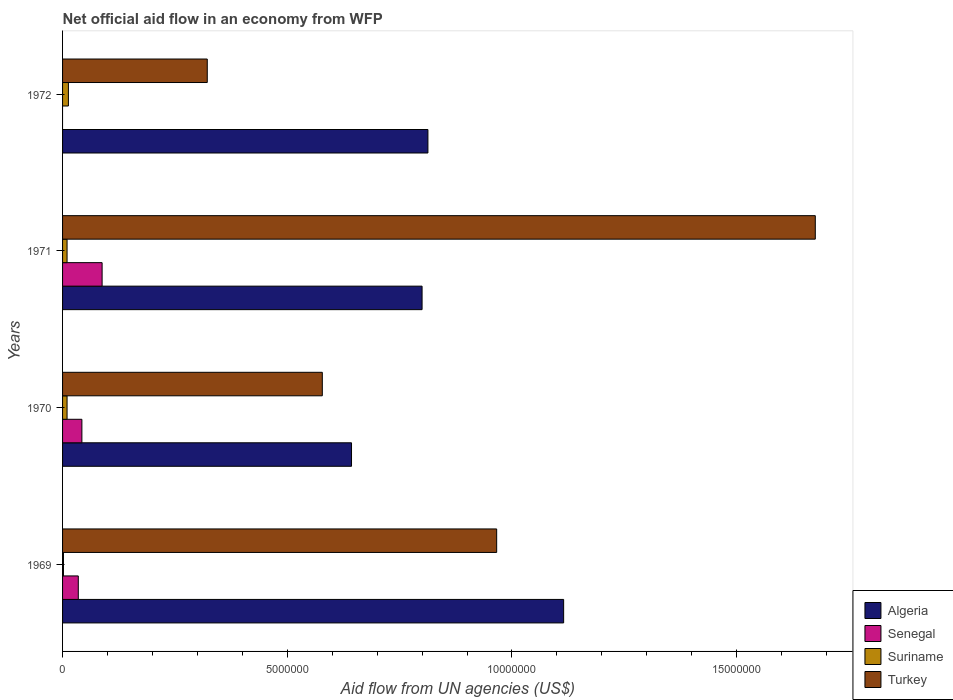How many different coloured bars are there?
Make the answer very short. 4. How many groups of bars are there?
Your response must be concise. 4. How many bars are there on the 3rd tick from the top?
Your answer should be compact. 4. How many bars are there on the 4th tick from the bottom?
Provide a succinct answer. 3. What is the label of the 2nd group of bars from the top?
Provide a short and direct response. 1971. In how many cases, is the number of bars for a given year not equal to the number of legend labels?
Provide a short and direct response. 1. What is the net official aid flow in Turkey in 1970?
Your answer should be very brief. 5.78e+06. Across all years, what is the maximum net official aid flow in Algeria?
Provide a short and direct response. 1.12e+07. Across all years, what is the minimum net official aid flow in Algeria?
Your answer should be very brief. 6.43e+06. What is the total net official aid flow in Senegal in the graph?
Your answer should be very brief. 1.66e+06. What is the difference between the net official aid flow in Algeria in 1970 and that in 1971?
Provide a succinct answer. -1.57e+06. What is the difference between the net official aid flow in Algeria in 1970 and the net official aid flow in Suriname in 1969?
Your answer should be compact. 6.41e+06. What is the average net official aid flow in Senegal per year?
Your answer should be very brief. 4.15e+05. In the year 1969, what is the difference between the net official aid flow in Senegal and net official aid flow in Turkey?
Your answer should be compact. -9.31e+06. In how many years, is the net official aid flow in Suriname greater than 4000000 US$?
Ensure brevity in your answer.  0. What is the ratio of the net official aid flow in Algeria in 1970 to that in 1971?
Offer a very short reply. 0.8. What is the difference between the highest and the second highest net official aid flow in Algeria?
Make the answer very short. 3.02e+06. In how many years, is the net official aid flow in Senegal greater than the average net official aid flow in Senegal taken over all years?
Ensure brevity in your answer.  2. Is it the case that in every year, the sum of the net official aid flow in Algeria and net official aid flow in Senegal is greater than the sum of net official aid flow in Turkey and net official aid flow in Suriname?
Make the answer very short. No. How many bars are there?
Offer a very short reply. 15. What is the difference between two consecutive major ticks on the X-axis?
Keep it short and to the point. 5.00e+06. Are the values on the major ticks of X-axis written in scientific E-notation?
Give a very brief answer. No. Does the graph contain any zero values?
Provide a short and direct response. Yes. Does the graph contain grids?
Make the answer very short. No. How are the legend labels stacked?
Provide a succinct answer. Vertical. What is the title of the graph?
Offer a very short reply. Net official aid flow in an economy from WFP. What is the label or title of the X-axis?
Keep it short and to the point. Aid flow from UN agencies (US$). What is the label or title of the Y-axis?
Your answer should be compact. Years. What is the Aid flow from UN agencies (US$) in Algeria in 1969?
Your response must be concise. 1.12e+07. What is the Aid flow from UN agencies (US$) in Senegal in 1969?
Keep it short and to the point. 3.50e+05. What is the Aid flow from UN agencies (US$) in Turkey in 1969?
Offer a terse response. 9.66e+06. What is the Aid flow from UN agencies (US$) of Algeria in 1970?
Your response must be concise. 6.43e+06. What is the Aid flow from UN agencies (US$) of Senegal in 1970?
Your answer should be very brief. 4.30e+05. What is the Aid flow from UN agencies (US$) in Turkey in 1970?
Ensure brevity in your answer.  5.78e+06. What is the Aid flow from UN agencies (US$) in Senegal in 1971?
Ensure brevity in your answer.  8.80e+05. What is the Aid flow from UN agencies (US$) of Suriname in 1971?
Your answer should be compact. 1.00e+05. What is the Aid flow from UN agencies (US$) of Turkey in 1971?
Provide a succinct answer. 1.68e+07. What is the Aid flow from UN agencies (US$) of Algeria in 1972?
Offer a very short reply. 8.13e+06. What is the Aid flow from UN agencies (US$) in Senegal in 1972?
Give a very brief answer. 0. What is the Aid flow from UN agencies (US$) in Turkey in 1972?
Provide a succinct answer. 3.22e+06. Across all years, what is the maximum Aid flow from UN agencies (US$) of Algeria?
Your response must be concise. 1.12e+07. Across all years, what is the maximum Aid flow from UN agencies (US$) in Senegal?
Your response must be concise. 8.80e+05. Across all years, what is the maximum Aid flow from UN agencies (US$) of Turkey?
Offer a terse response. 1.68e+07. Across all years, what is the minimum Aid flow from UN agencies (US$) in Algeria?
Provide a succinct answer. 6.43e+06. Across all years, what is the minimum Aid flow from UN agencies (US$) of Suriname?
Ensure brevity in your answer.  2.00e+04. Across all years, what is the minimum Aid flow from UN agencies (US$) of Turkey?
Offer a terse response. 3.22e+06. What is the total Aid flow from UN agencies (US$) in Algeria in the graph?
Your answer should be very brief. 3.37e+07. What is the total Aid flow from UN agencies (US$) in Senegal in the graph?
Provide a short and direct response. 1.66e+06. What is the total Aid flow from UN agencies (US$) in Suriname in the graph?
Ensure brevity in your answer.  3.50e+05. What is the total Aid flow from UN agencies (US$) in Turkey in the graph?
Offer a very short reply. 3.54e+07. What is the difference between the Aid flow from UN agencies (US$) in Algeria in 1969 and that in 1970?
Offer a terse response. 4.72e+06. What is the difference between the Aid flow from UN agencies (US$) of Turkey in 1969 and that in 1970?
Offer a terse response. 3.88e+06. What is the difference between the Aid flow from UN agencies (US$) of Algeria in 1969 and that in 1971?
Provide a short and direct response. 3.15e+06. What is the difference between the Aid flow from UN agencies (US$) in Senegal in 1969 and that in 1971?
Provide a short and direct response. -5.30e+05. What is the difference between the Aid flow from UN agencies (US$) of Turkey in 1969 and that in 1971?
Your answer should be compact. -7.09e+06. What is the difference between the Aid flow from UN agencies (US$) in Algeria in 1969 and that in 1972?
Your response must be concise. 3.02e+06. What is the difference between the Aid flow from UN agencies (US$) in Suriname in 1969 and that in 1972?
Keep it short and to the point. -1.10e+05. What is the difference between the Aid flow from UN agencies (US$) of Turkey in 1969 and that in 1972?
Provide a short and direct response. 6.44e+06. What is the difference between the Aid flow from UN agencies (US$) in Algeria in 1970 and that in 1971?
Your response must be concise. -1.57e+06. What is the difference between the Aid flow from UN agencies (US$) of Senegal in 1970 and that in 1971?
Make the answer very short. -4.50e+05. What is the difference between the Aid flow from UN agencies (US$) in Suriname in 1970 and that in 1971?
Give a very brief answer. 0. What is the difference between the Aid flow from UN agencies (US$) in Turkey in 1970 and that in 1971?
Provide a short and direct response. -1.10e+07. What is the difference between the Aid flow from UN agencies (US$) of Algeria in 1970 and that in 1972?
Provide a succinct answer. -1.70e+06. What is the difference between the Aid flow from UN agencies (US$) in Turkey in 1970 and that in 1972?
Your answer should be very brief. 2.56e+06. What is the difference between the Aid flow from UN agencies (US$) of Algeria in 1971 and that in 1972?
Offer a terse response. -1.30e+05. What is the difference between the Aid flow from UN agencies (US$) of Turkey in 1971 and that in 1972?
Offer a very short reply. 1.35e+07. What is the difference between the Aid flow from UN agencies (US$) of Algeria in 1969 and the Aid flow from UN agencies (US$) of Senegal in 1970?
Ensure brevity in your answer.  1.07e+07. What is the difference between the Aid flow from UN agencies (US$) in Algeria in 1969 and the Aid flow from UN agencies (US$) in Suriname in 1970?
Offer a terse response. 1.10e+07. What is the difference between the Aid flow from UN agencies (US$) in Algeria in 1969 and the Aid flow from UN agencies (US$) in Turkey in 1970?
Provide a succinct answer. 5.37e+06. What is the difference between the Aid flow from UN agencies (US$) of Senegal in 1969 and the Aid flow from UN agencies (US$) of Suriname in 1970?
Your answer should be very brief. 2.50e+05. What is the difference between the Aid flow from UN agencies (US$) of Senegal in 1969 and the Aid flow from UN agencies (US$) of Turkey in 1970?
Offer a terse response. -5.43e+06. What is the difference between the Aid flow from UN agencies (US$) of Suriname in 1969 and the Aid flow from UN agencies (US$) of Turkey in 1970?
Ensure brevity in your answer.  -5.76e+06. What is the difference between the Aid flow from UN agencies (US$) of Algeria in 1969 and the Aid flow from UN agencies (US$) of Senegal in 1971?
Offer a very short reply. 1.03e+07. What is the difference between the Aid flow from UN agencies (US$) in Algeria in 1969 and the Aid flow from UN agencies (US$) in Suriname in 1971?
Provide a short and direct response. 1.10e+07. What is the difference between the Aid flow from UN agencies (US$) of Algeria in 1969 and the Aid flow from UN agencies (US$) of Turkey in 1971?
Offer a very short reply. -5.60e+06. What is the difference between the Aid flow from UN agencies (US$) of Senegal in 1969 and the Aid flow from UN agencies (US$) of Turkey in 1971?
Keep it short and to the point. -1.64e+07. What is the difference between the Aid flow from UN agencies (US$) in Suriname in 1969 and the Aid flow from UN agencies (US$) in Turkey in 1971?
Offer a terse response. -1.67e+07. What is the difference between the Aid flow from UN agencies (US$) in Algeria in 1969 and the Aid flow from UN agencies (US$) in Suriname in 1972?
Provide a short and direct response. 1.10e+07. What is the difference between the Aid flow from UN agencies (US$) in Algeria in 1969 and the Aid flow from UN agencies (US$) in Turkey in 1972?
Your answer should be very brief. 7.93e+06. What is the difference between the Aid flow from UN agencies (US$) in Senegal in 1969 and the Aid flow from UN agencies (US$) in Suriname in 1972?
Keep it short and to the point. 2.20e+05. What is the difference between the Aid flow from UN agencies (US$) in Senegal in 1969 and the Aid flow from UN agencies (US$) in Turkey in 1972?
Your answer should be compact. -2.87e+06. What is the difference between the Aid flow from UN agencies (US$) of Suriname in 1969 and the Aid flow from UN agencies (US$) of Turkey in 1972?
Offer a very short reply. -3.20e+06. What is the difference between the Aid flow from UN agencies (US$) in Algeria in 1970 and the Aid flow from UN agencies (US$) in Senegal in 1971?
Your response must be concise. 5.55e+06. What is the difference between the Aid flow from UN agencies (US$) of Algeria in 1970 and the Aid flow from UN agencies (US$) of Suriname in 1971?
Your answer should be compact. 6.33e+06. What is the difference between the Aid flow from UN agencies (US$) in Algeria in 1970 and the Aid flow from UN agencies (US$) in Turkey in 1971?
Make the answer very short. -1.03e+07. What is the difference between the Aid flow from UN agencies (US$) in Senegal in 1970 and the Aid flow from UN agencies (US$) in Turkey in 1971?
Provide a succinct answer. -1.63e+07. What is the difference between the Aid flow from UN agencies (US$) of Suriname in 1970 and the Aid flow from UN agencies (US$) of Turkey in 1971?
Your answer should be very brief. -1.66e+07. What is the difference between the Aid flow from UN agencies (US$) in Algeria in 1970 and the Aid flow from UN agencies (US$) in Suriname in 1972?
Make the answer very short. 6.30e+06. What is the difference between the Aid flow from UN agencies (US$) in Algeria in 1970 and the Aid flow from UN agencies (US$) in Turkey in 1972?
Offer a very short reply. 3.21e+06. What is the difference between the Aid flow from UN agencies (US$) of Senegal in 1970 and the Aid flow from UN agencies (US$) of Suriname in 1972?
Your answer should be very brief. 3.00e+05. What is the difference between the Aid flow from UN agencies (US$) of Senegal in 1970 and the Aid flow from UN agencies (US$) of Turkey in 1972?
Ensure brevity in your answer.  -2.79e+06. What is the difference between the Aid flow from UN agencies (US$) in Suriname in 1970 and the Aid flow from UN agencies (US$) in Turkey in 1972?
Your response must be concise. -3.12e+06. What is the difference between the Aid flow from UN agencies (US$) in Algeria in 1971 and the Aid flow from UN agencies (US$) in Suriname in 1972?
Make the answer very short. 7.87e+06. What is the difference between the Aid flow from UN agencies (US$) in Algeria in 1971 and the Aid flow from UN agencies (US$) in Turkey in 1972?
Your answer should be compact. 4.78e+06. What is the difference between the Aid flow from UN agencies (US$) of Senegal in 1971 and the Aid flow from UN agencies (US$) of Suriname in 1972?
Your answer should be compact. 7.50e+05. What is the difference between the Aid flow from UN agencies (US$) of Senegal in 1971 and the Aid flow from UN agencies (US$) of Turkey in 1972?
Give a very brief answer. -2.34e+06. What is the difference between the Aid flow from UN agencies (US$) of Suriname in 1971 and the Aid flow from UN agencies (US$) of Turkey in 1972?
Provide a short and direct response. -3.12e+06. What is the average Aid flow from UN agencies (US$) in Algeria per year?
Offer a very short reply. 8.43e+06. What is the average Aid flow from UN agencies (US$) of Senegal per year?
Ensure brevity in your answer.  4.15e+05. What is the average Aid flow from UN agencies (US$) of Suriname per year?
Ensure brevity in your answer.  8.75e+04. What is the average Aid flow from UN agencies (US$) of Turkey per year?
Provide a succinct answer. 8.85e+06. In the year 1969, what is the difference between the Aid flow from UN agencies (US$) in Algeria and Aid flow from UN agencies (US$) in Senegal?
Make the answer very short. 1.08e+07. In the year 1969, what is the difference between the Aid flow from UN agencies (US$) in Algeria and Aid flow from UN agencies (US$) in Suriname?
Make the answer very short. 1.11e+07. In the year 1969, what is the difference between the Aid flow from UN agencies (US$) in Algeria and Aid flow from UN agencies (US$) in Turkey?
Make the answer very short. 1.49e+06. In the year 1969, what is the difference between the Aid flow from UN agencies (US$) of Senegal and Aid flow from UN agencies (US$) of Turkey?
Your answer should be very brief. -9.31e+06. In the year 1969, what is the difference between the Aid flow from UN agencies (US$) in Suriname and Aid flow from UN agencies (US$) in Turkey?
Make the answer very short. -9.64e+06. In the year 1970, what is the difference between the Aid flow from UN agencies (US$) of Algeria and Aid flow from UN agencies (US$) of Suriname?
Ensure brevity in your answer.  6.33e+06. In the year 1970, what is the difference between the Aid flow from UN agencies (US$) in Algeria and Aid flow from UN agencies (US$) in Turkey?
Make the answer very short. 6.50e+05. In the year 1970, what is the difference between the Aid flow from UN agencies (US$) in Senegal and Aid flow from UN agencies (US$) in Turkey?
Provide a succinct answer. -5.35e+06. In the year 1970, what is the difference between the Aid flow from UN agencies (US$) in Suriname and Aid flow from UN agencies (US$) in Turkey?
Offer a terse response. -5.68e+06. In the year 1971, what is the difference between the Aid flow from UN agencies (US$) in Algeria and Aid flow from UN agencies (US$) in Senegal?
Make the answer very short. 7.12e+06. In the year 1971, what is the difference between the Aid flow from UN agencies (US$) in Algeria and Aid flow from UN agencies (US$) in Suriname?
Offer a terse response. 7.90e+06. In the year 1971, what is the difference between the Aid flow from UN agencies (US$) in Algeria and Aid flow from UN agencies (US$) in Turkey?
Provide a short and direct response. -8.75e+06. In the year 1971, what is the difference between the Aid flow from UN agencies (US$) in Senegal and Aid flow from UN agencies (US$) in Suriname?
Make the answer very short. 7.80e+05. In the year 1971, what is the difference between the Aid flow from UN agencies (US$) in Senegal and Aid flow from UN agencies (US$) in Turkey?
Give a very brief answer. -1.59e+07. In the year 1971, what is the difference between the Aid flow from UN agencies (US$) of Suriname and Aid flow from UN agencies (US$) of Turkey?
Provide a succinct answer. -1.66e+07. In the year 1972, what is the difference between the Aid flow from UN agencies (US$) of Algeria and Aid flow from UN agencies (US$) of Turkey?
Give a very brief answer. 4.91e+06. In the year 1972, what is the difference between the Aid flow from UN agencies (US$) in Suriname and Aid flow from UN agencies (US$) in Turkey?
Your answer should be very brief. -3.09e+06. What is the ratio of the Aid flow from UN agencies (US$) in Algeria in 1969 to that in 1970?
Offer a terse response. 1.73. What is the ratio of the Aid flow from UN agencies (US$) in Senegal in 1969 to that in 1970?
Make the answer very short. 0.81. What is the ratio of the Aid flow from UN agencies (US$) of Suriname in 1969 to that in 1970?
Provide a succinct answer. 0.2. What is the ratio of the Aid flow from UN agencies (US$) of Turkey in 1969 to that in 1970?
Provide a short and direct response. 1.67. What is the ratio of the Aid flow from UN agencies (US$) in Algeria in 1969 to that in 1971?
Provide a short and direct response. 1.39. What is the ratio of the Aid flow from UN agencies (US$) in Senegal in 1969 to that in 1971?
Keep it short and to the point. 0.4. What is the ratio of the Aid flow from UN agencies (US$) in Turkey in 1969 to that in 1971?
Give a very brief answer. 0.58. What is the ratio of the Aid flow from UN agencies (US$) in Algeria in 1969 to that in 1972?
Ensure brevity in your answer.  1.37. What is the ratio of the Aid flow from UN agencies (US$) in Suriname in 1969 to that in 1972?
Ensure brevity in your answer.  0.15. What is the ratio of the Aid flow from UN agencies (US$) in Turkey in 1969 to that in 1972?
Keep it short and to the point. 3. What is the ratio of the Aid flow from UN agencies (US$) of Algeria in 1970 to that in 1971?
Provide a succinct answer. 0.8. What is the ratio of the Aid flow from UN agencies (US$) of Senegal in 1970 to that in 1971?
Keep it short and to the point. 0.49. What is the ratio of the Aid flow from UN agencies (US$) of Turkey in 1970 to that in 1971?
Provide a succinct answer. 0.35. What is the ratio of the Aid flow from UN agencies (US$) in Algeria in 1970 to that in 1972?
Your answer should be very brief. 0.79. What is the ratio of the Aid flow from UN agencies (US$) in Suriname in 1970 to that in 1972?
Make the answer very short. 0.77. What is the ratio of the Aid flow from UN agencies (US$) of Turkey in 1970 to that in 1972?
Provide a succinct answer. 1.79. What is the ratio of the Aid flow from UN agencies (US$) in Algeria in 1971 to that in 1972?
Provide a short and direct response. 0.98. What is the ratio of the Aid flow from UN agencies (US$) of Suriname in 1971 to that in 1972?
Make the answer very short. 0.77. What is the ratio of the Aid flow from UN agencies (US$) of Turkey in 1971 to that in 1972?
Your answer should be compact. 5.2. What is the difference between the highest and the second highest Aid flow from UN agencies (US$) in Algeria?
Your answer should be compact. 3.02e+06. What is the difference between the highest and the second highest Aid flow from UN agencies (US$) of Senegal?
Give a very brief answer. 4.50e+05. What is the difference between the highest and the second highest Aid flow from UN agencies (US$) in Suriname?
Provide a short and direct response. 3.00e+04. What is the difference between the highest and the second highest Aid flow from UN agencies (US$) of Turkey?
Your answer should be compact. 7.09e+06. What is the difference between the highest and the lowest Aid flow from UN agencies (US$) of Algeria?
Offer a terse response. 4.72e+06. What is the difference between the highest and the lowest Aid flow from UN agencies (US$) of Senegal?
Provide a succinct answer. 8.80e+05. What is the difference between the highest and the lowest Aid flow from UN agencies (US$) of Turkey?
Offer a very short reply. 1.35e+07. 